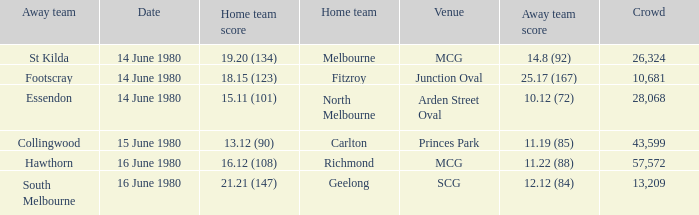On what date the footscray's away game? 14 June 1980. 